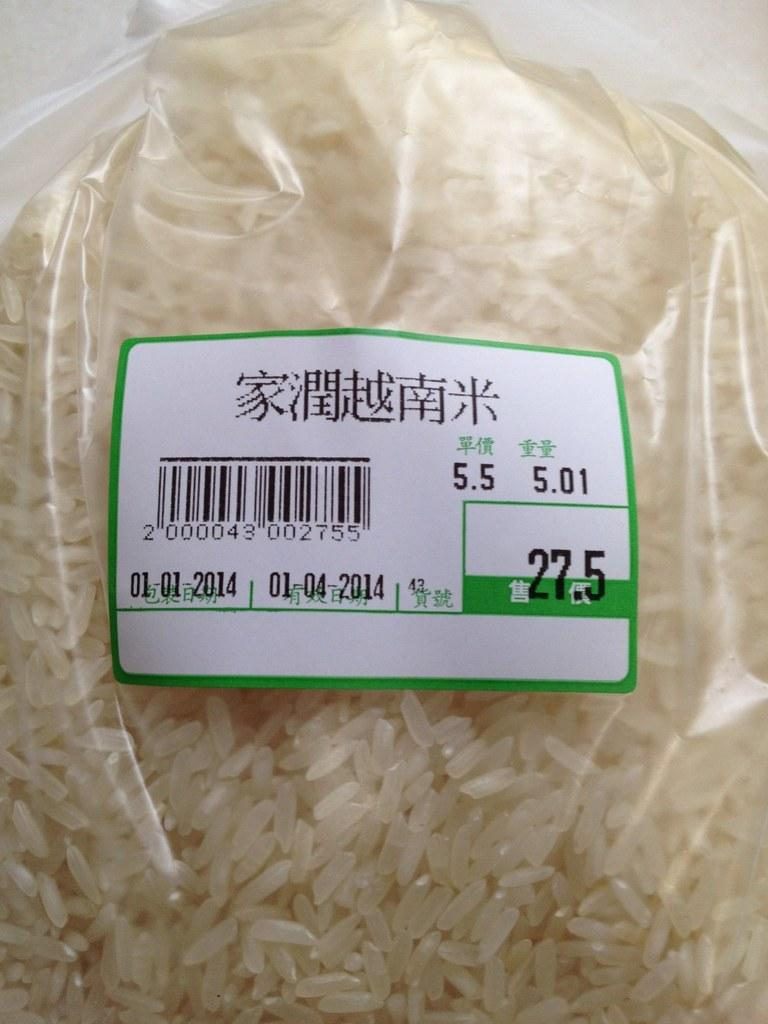What is the main subject in the center of the image? There is rice in the center of the image. Is the rice visible or covered? The rice is covered. What else can be seen in the image besides the rice? There is a sticker in the image. What type of road is visible in the image? There is no road present in the image; it features rice covered by a lid and a sticker. 